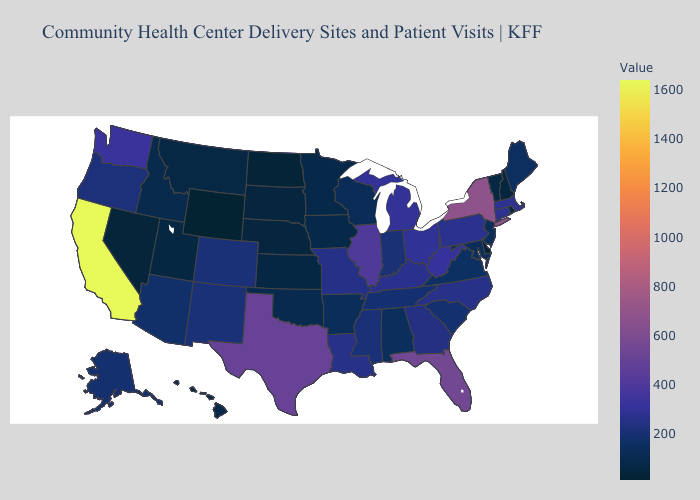Does Virginia have a higher value than New York?
Keep it brief. No. Does Mississippi have a lower value than New York?
Write a very short answer. Yes. 